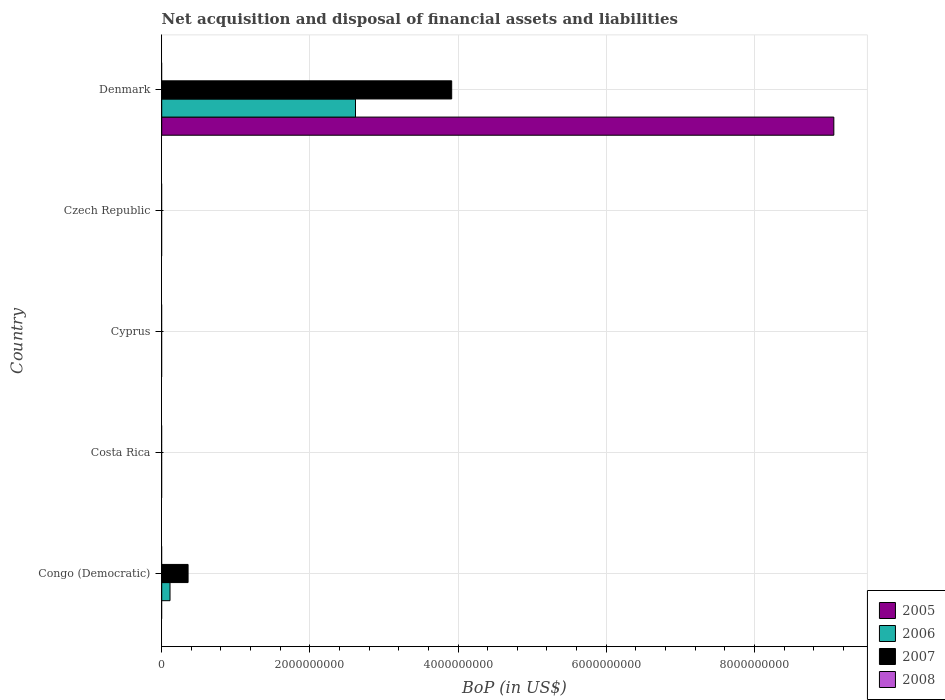How many bars are there on the 1st tick from the top?
Your answer should be compact. 3. How many bars are there on the 1st tick from the bottom?
Your answer should be compact. 2. What is the label of the 4th group of bars from the top?
Ensure brevity in your answer.  Costa Rica. What is the Balance of Payments in 2008 in Costa Rica?
Ensure brevity in your answer.  0. Across all countries, what is the maximum Balance of Payments in 2007?
Provide a succinct answer. 3.91e+09. What is the total Balance of Payments in 2005 in the graph?
Offer a terse response. 9.07e+09. What is the difference between the Balance of Payments in 2007 in Congo (Democratic) and the Balance of Payments in 2008 in Czech Republic?
Your answer should be very brief. 3.56e+08. What is the average Balance of Payments in 2006 per country?
Make the answer very short. 5.46e+08. What is the difference between the Balance of Payments in 2006 and Balance of Payments in 2007 in Denmark?
Make the answer very short. -1.30e+09. In how many countries, is the Balance of Payments in 2008 greater than 5600000000 US$?
Your answer should be compact. 0. Is the difference between the Balance of Payments in 2006 in Congo (Democratic) and Denmark greater than the difference between the Balance of Payments in 2007 in Congo (Democratic) and Denmark?
Offer a terse response. Yes. What is the difference between the highest and the lowest Balance of Payments in 2005?
Make the answer very short. 9.07e+09. Is it the case that in every country, the sum of the Balance of Payments in 2005 and Balance of Payments in 2006 is greater than the sum of Balance of Payments in 2008 and Balance of Payments in 2007?
Give a very brief answer. No. How many bars are there?
Ensure brevity in your answer.  5. How many countries are there in the graph?
Offer a terse response. 5. What is the title of the graph?
Your answer should be very brief. Net acquisition and disposal of financial assets and liabilities. What is the label or title of the X-axis?
Offer a very short reply. BoP (in US$). What is the label or title of the Y-axis?
Make the answer very short. Country. What is the BoP (in US$) of 2005 in Congo (Democratic)?
Offer a terse response. 0. What is the BoP (in US$) of 2006 in Congo (Democratic)?
Keep it short and to the point. 1.12e+08. What is the BoP (in US$) in 2007 in Congo (Democratic)?
Your answer should be very brief. 3.56e+08. What is the BoP (in US$) in 2005 in Costa Rica?
Your response must be concise. 0. What is the BoP (in US$) of 2006 in Costa Rica?
Your answer should be very brief. 0. What is the BoP (in US$) in 2007 in Costa Rica?
Your answer should be compact. 0. What is the BoP (in US$) of 2006 in Cyprus?
Offer a terse response. 0. What is the BoP (in US$) in 2007 in Cyprus?
Provide a succinct answer. 0. What is the BoP (in US$) in 2008 in Cyprus?
Your answer should be compact. 0. What is the BoP (in US$) of 2005 in Czech Republic?
Keep it short and to the point. 0. What is the BoP (in US$) in 2007 in Czech Republic?
Provide a succinct answer. 0. What is the BoP (in US$) in 2005 in Denmark?
Offer a terse response. 9.07e+09. What is the BoP (in US$) in 2006 in Denmark?
Ensure brevity in your answer.  2.62e+09. What is the BoP (in US$) in 2007 in Denmark?
Provide a succinct answer. 3.91e+09. Across all countries, what is the maximum BoP (in US$) in 2005?
Your answer should be very brief. 9.07e+09. Across all countries, what is the maximum BoP (in US$) of 2006?
Your response must be concise. 2.62e+09. Across all countries, what is the maximum BoP (in US$) in 2007?
Keep it short and to the point. 3.91e+09. Across all countries, what is the minimum BoP (in US$) of 2006?
Ensure brevity in your answer.  0. Across all countries, what is the minimum BoP (in US$) of 2007?
Keep it short and to the point. 0. What is the total BoP (in US$) of 2005 in the graph?
Offer a very short reply. 9.07e+09. What is the total BoP (in US$) of 2006 in the graph?
Your answer should be very brief. 2.73e+09. What is the total BoP (in US$) in 2007 in the graph?
Provide a short and direct response. 4.27e+09. What is the total BoP (in US$) in 2008 in the graph?
Provide a short and direct response. 0. What is the difference between the BoP (in US$) of 2006 in Congo (Democratic) and that in Denmark?
Your answer should be compact. -2.50e+09. What is the difference between the BoP (in US$) in 2007 in Congo (Democratic) and that in Denmark?
Offer a terse response. -3.56e+09. What is the difference between the BoP (in US$) in 2006 in Congo (Democratic) and the BoP (in US$) in 2007 in Denmark?
Provide a short and direct response. -3.80e+09. What is the average BoP (in US$) of 2005 per country?
Offer a terse response. 1.81e+09. What is the average BoP (in US$) in 2006 per country?
Give a very brief answer. 5.46e+08. What is the average BoP (in US$) of 2007 per country?
Offer a terse response. 8.54e+08. What is the difference between the BoP (in US$) in 2006 and BoP (in US$) in 2007 in Congo (Democratic)?
Offer a very short reply. -2.44e+08. What is the difference between the BoP (in US$) in 2005 and BoP (in US$) in 2006 in Denmark?
Give a very brief answer. 6.46e+09. What is the difference between the BoP (in US$) of 2005 and BoP (in US$) of 2007 in Denmark?
Offer a terse response. 5.16e+09. What is the difference between the BoP (in US$) of 2006 and BoP (in US$) of 2007 in Denmark?
Give a very brief answer. -1.30e+09. What is the ratio of the BoP (in US$) in 2006 in Congo (Democratic) to that in Denmark?
Provide a succinct answer. 0.04. What is the ratio of the BoP (in US$) in 2007 in Congo (Democratic) to that in Denmark?
Your answer should be compact. 0.09. What is the difference between the highest and the lowest BoP (in US$) of 2005?
Keep it short and to the point. 9.07e+09. What is the difference between the highest and the lowest BoP (in US$) in 2006?
Your answer should be very brief. 2.62e+09. What is the difference between the highest and the lowest BoP (in US$) of 2007?
Your answer should be very brief. 3.91e+09. 